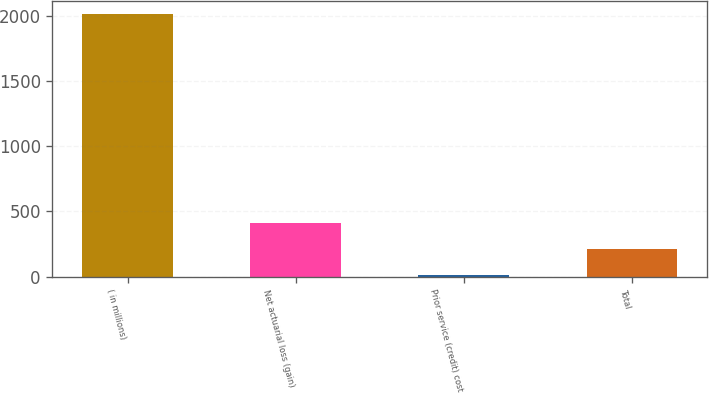<chart> <loc_0><loc_0><loc_500><loc_500><bar_chart><fcel>( in millions)<fcel>Net actuarial loss (gain)<fcel>Prior service (credit) cost<fcel>Total<nl><fcel>2010<fcel>412.16<fcel>12.7<fcel>212.43<nl></chart> 